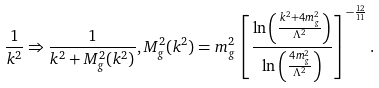Convert formula to latex. <formula><loc_0><loc_0><loc_500><loc_500>\frac { 1 } { k ^ { 2 } } \Rightarrow \frac { 1 } { k ^ { 2 } + M ^ { 2 } _ { g } ( k ^ { 2 } ) } , M ^ { 2 } _ { g } ( k ^ { 2 } ) = m ^ { 2 } _ { g } \left [ \frac { \ln \left ( \frac { k ^ { 2 } + 4 m ^ { 2 } _ { g } } { \Lambda ^ { 2 } } \right ) } { \ln \left ( \frac { 4 m ^ { 2 } _ { g } } { \Lambda ^ { 2 } } \right ) } \right ] ^ { - \frac { 1 2 } { 1 1 } } .</formula> 